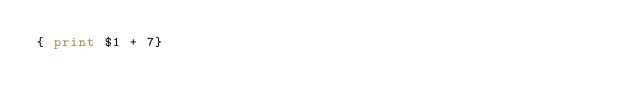<code> <loc_0><loc_0><loc_500><loc_500><_Awk_>{ print $1 + 7}
</code> 